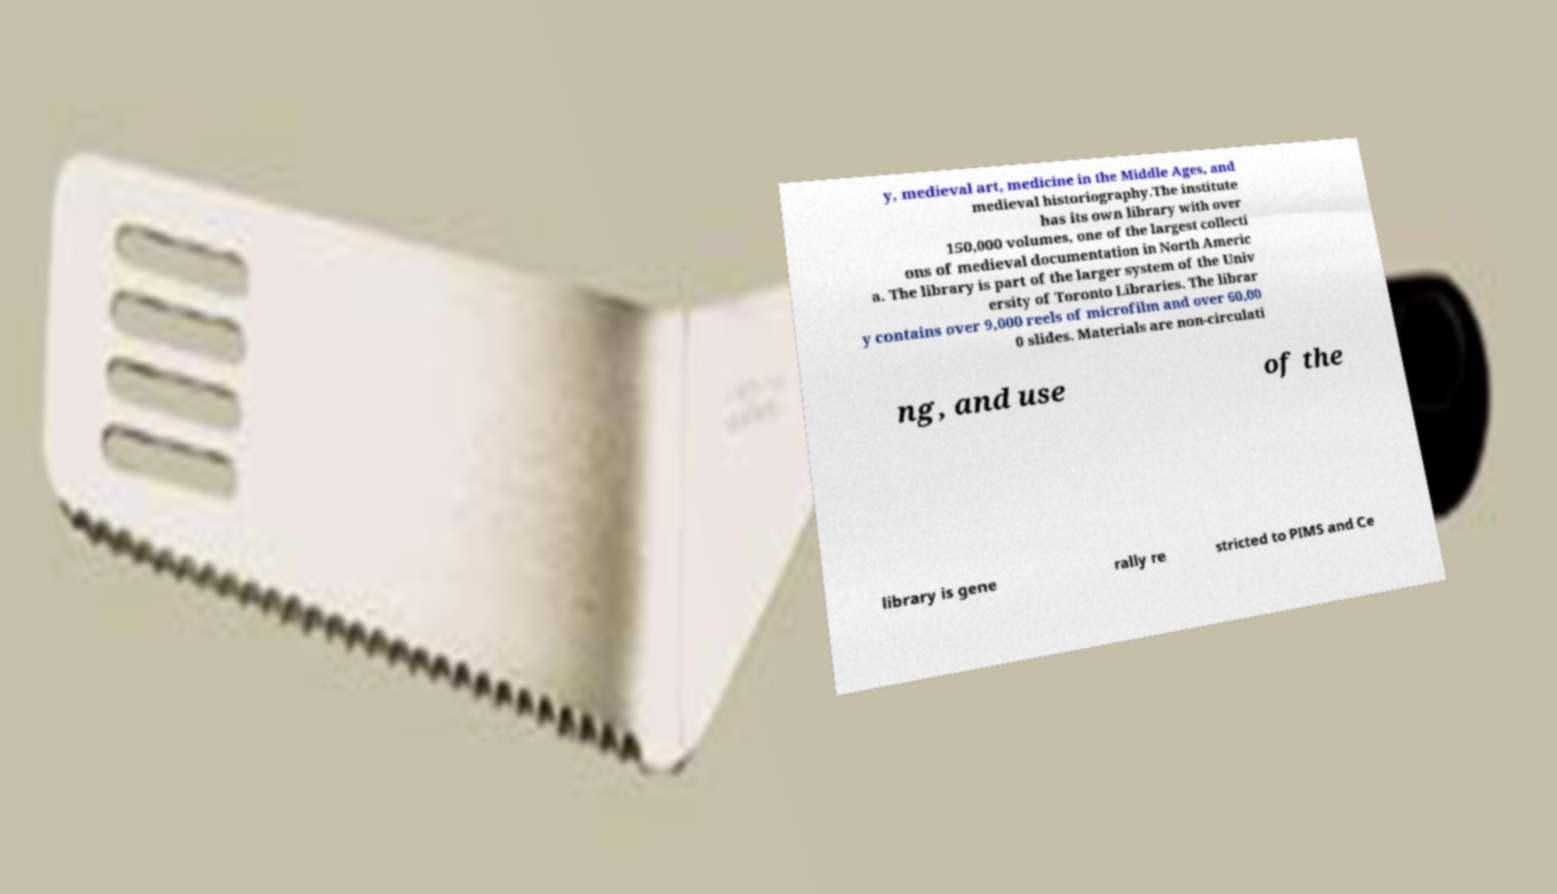What messages or text are displayed in this image? I need them in a readable, typed format. y, medieval art, medicine in the Middle Ages, and medieval historiography.The institute has its own library with over 150,000 volumes, one of the largest collecti ons of medieval documentation in North Americ a. The library is part of the larger system of the Univ ersity of Toronto Libraries. The librar y contains over 9,000 reels of microfilm and over 60,00 0 slides. Materials are non-circulati ng, and use of the library is gene rally re stricted to PIMS and Ce 